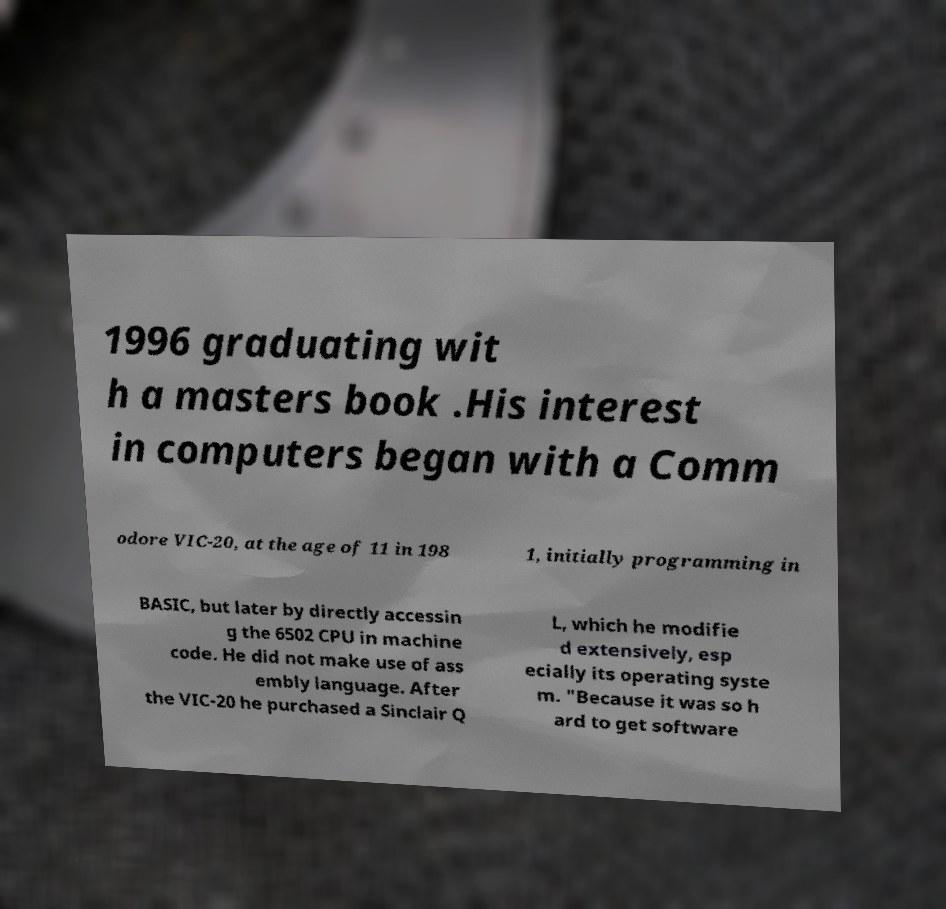Could you extract and type out the text from this image? 1996 graduating wit h a masters book .His interest in computers began with a Comm odore VIC-20, at the age of 11 in 198 1, initially programming in BASIC, but later by directly accessin g the 6502 CPU in machine code. He did not make use of ass embly language. After the VIC-20 he purchased a Sinclair Q L, which he modifie d extensively, esp ecially its operating syste m. "Because it was so h ard to get software 